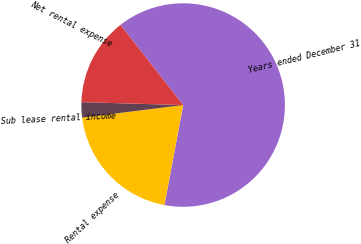<chart> <loc_0><loc_0><loc_500><loc_500><pie_chart><fcel>Years ended December 31<fcel>Rental expense<fcel>Sub lease rental income<fcel>Net rental expense<nl><fcel>63.51%<fcel>20.08%<fcel>2.43%<fcel>13.98%<nl></chart> 